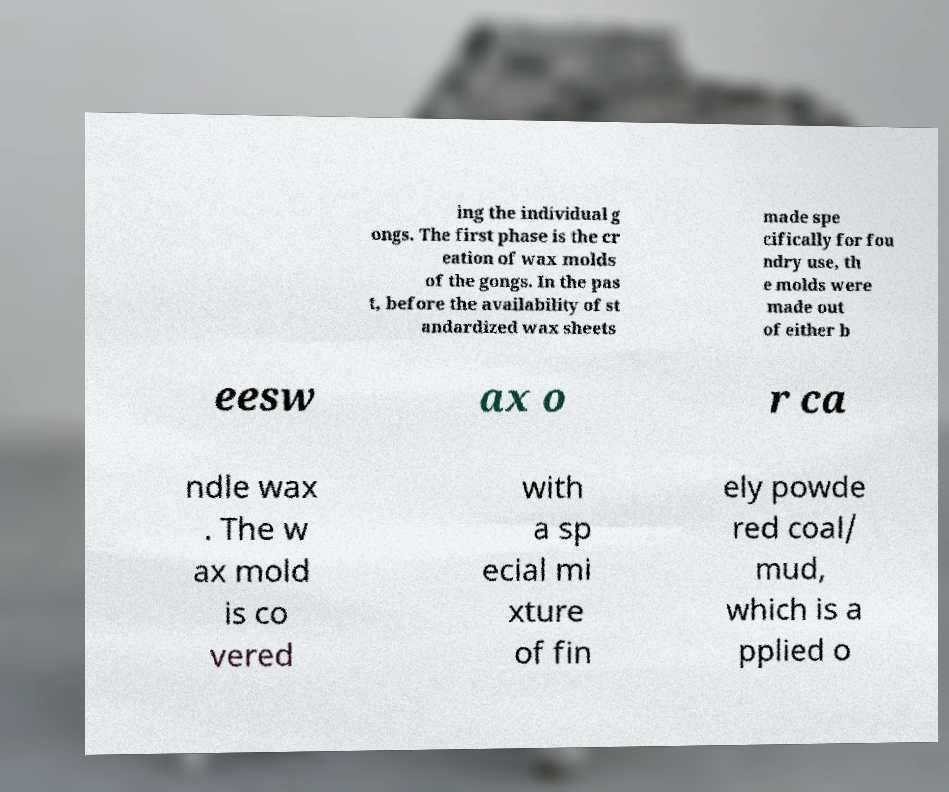I need the written content from this picture converted into text. Can you do that? ing the individual g ongs. The first phase is the cr eation of wax molds of the gongs. In the pas t, before the availability of st andardized wax sheets made spe cifically for fou ndry use, th e molds were made out of either b eesw ax o r ca ndle wax . The w ax mold is co vered with a sp ecial mi xture of fin ely powde red coal/ mud, which is a pplied o 